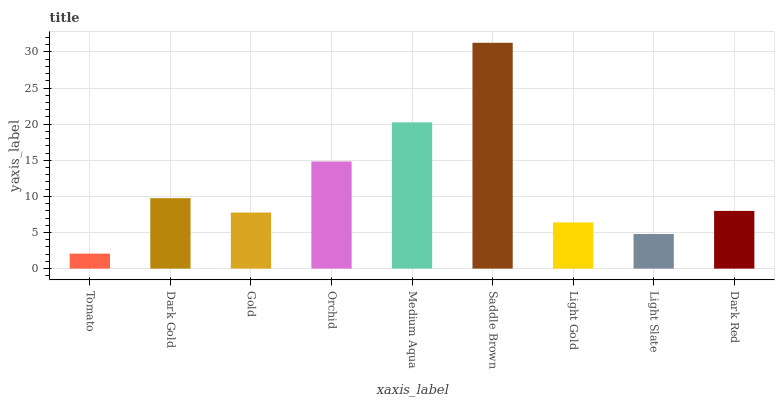Is Dark Gold the minimum?
Answer yes or no. No. Is Dark Gold the maximum?
Answer yes or no. No. Is Dark Gold greater than Tomato?
Answer yes or no. Yes. Is Tomato less than Dark Gold?
Answer yes or no. Yes. Is Tomato greater than Dark Gold?
Answer yes or no. No. Is Dark Gold less than Tomato?
Answer yes or no. No. Is Dark Red the high median?
Answer yes or no. Yes. Is Dark Red the low median?
Answer yes or no. Yes. Is Dark Gold the high median?
Answer yes or no. No. Is Medium Aqua the low median?
Answer yes or no. No. 